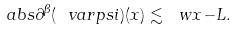Convert formula to latex. <formula><loc_0><loc_0><loc_500><loc_500>\ a b s { \partial ^ { \beta } ( \ v a r p s i ) ( x ) } \lesssim \ w { x } { - L } .</formula> 